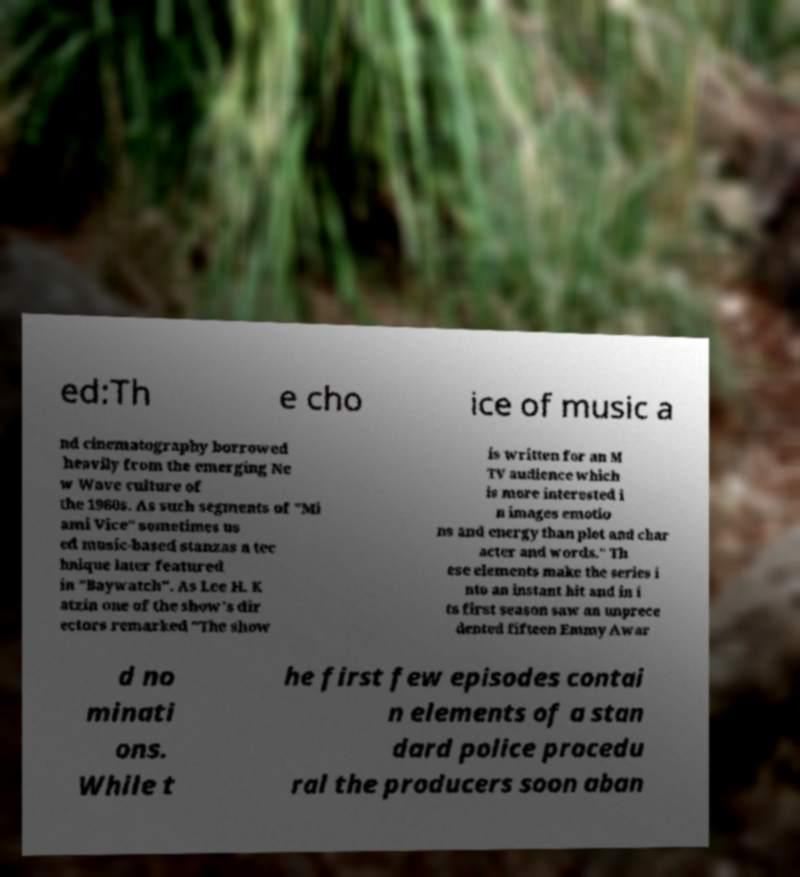Could you assist in decoding the text presented in this image and type it out clearly? ed:Th e cho ice of music a nd cinematography borrowed heavily from the emerging Ne w Wave culture of the 1980s. As such segments of "Mi ami Vice" sometimes us ed music-based stanzas a tec hnique later featured in "Baywatch". As Lee H. K atzin one of the show's dir ectors remarked "The show is written for an M TV audience which is more interested i n images emotio ns and energy than plot and char acter and words." Th ese elements make the series i nto an instant hit and in i ts first season saw an unprece dented fifteen Emmy Awar d no minati ons. While t he first few episodes contai n elements of a stan dard police procedu ral the producers soon aban 